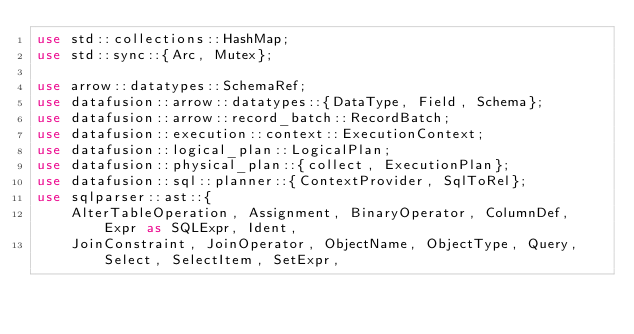Convert code to text. <code><loc_0><loc_0><loc_500><loc_500><_Rust_>use std::collections::HashMap;
use std::sync::{Arc, Mutex};

use arrow::datatypes::SchemaRef;
use datafusion::arrow::datatypes::{DataType, Field, Schema};
use datafusion::arrow::record_batch::RecordBatch;
use datafusion::execution::context::ExecutionContext;
use datafusion::logical_plan::LogicalPlan;
use datafusion::physical_plan::{collect, ExecutionPlan};
use datafusion::sql::planner::{ContextProvider, SqlToRel};
use sqlparser::ast::{
    AlterTableOperation, Assignment, BinaryOperator, ColumnDef, Expr as SQLExpr, Ident,
    JoinConstraint, JoinOperator, ObjectName, ObjectType, Query, Select, SelectItem, SetExpr,</code> 